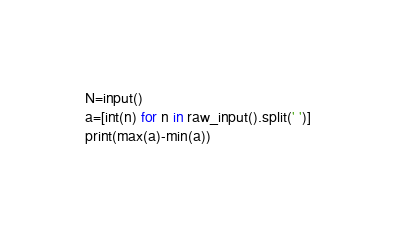Convert code to text. <code><loc_0><loc_0><loc_500><loc_500><_Python_>N=input()
a=[int(n) for n in raw_input().split(' ')]
print(max(a)-min(a))</code> 